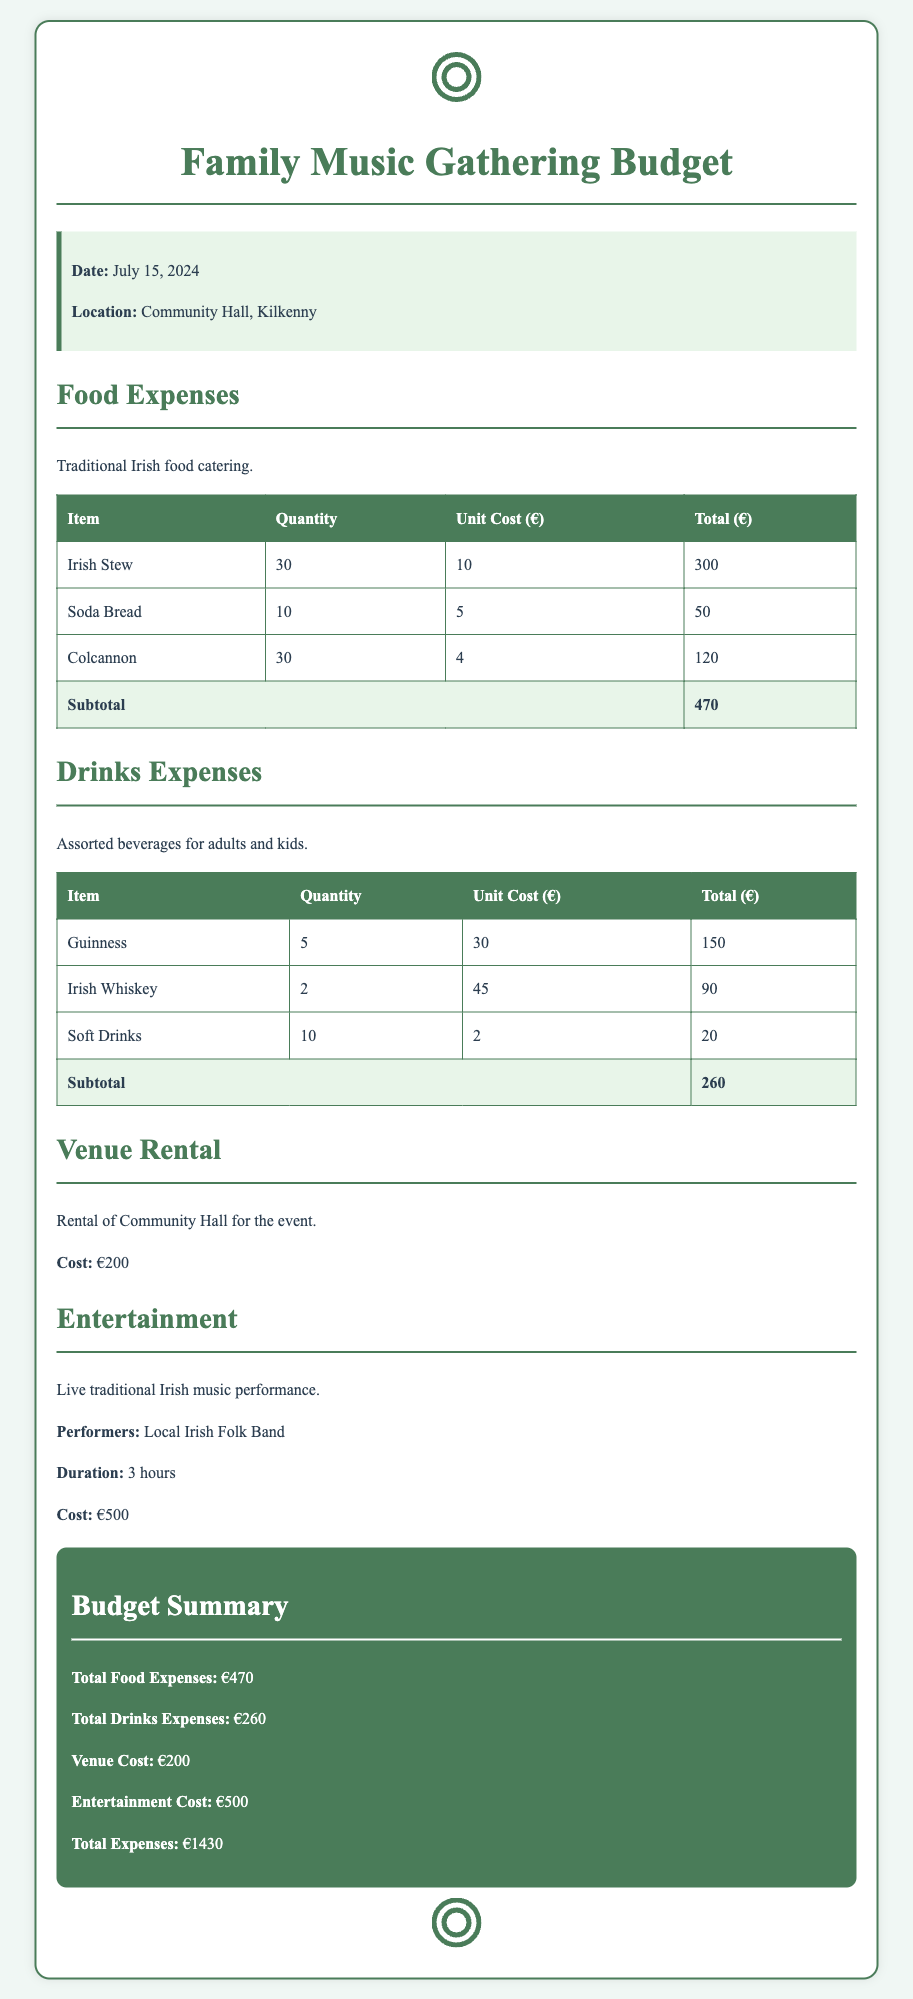What is the date of the gathering? The date of the gathering is mentioned in the document as July 15, 2024.
Answer: July 15, 2024 What is the location of the event? The location of the event is specified as Community Hall, Kilkenny.
Answer: Community Hall, Kilkenny How much does the venue rental cost? The cost of renting the venue is provided as €200.
Answer: €200 What is the total cost for food? The total cost for food is noted in the budget as €470.
Answer: €470 How many drinks of Guinness will be purchased? The quantity of Guinness drinks needed is highlighted as 5.
Answer: 5 What is the total expense for drinks? The total expense for drinks is calculated and shown as €260.
Answer: €260 Who is performing at the event? The performers for the event are identified as a Local Irish Folk Band.
Answer: Local Irish Folk Band What is the total cost for entertainment? The document states the entertainment cost as €500.
Answer: €500 What is the total budget for the event? The total expenses for the gathering are summarized to €1430.
Answer: €1430 